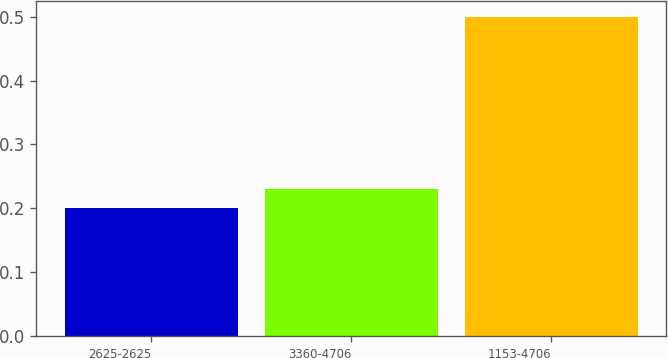Convert chart to OTSL. <chart><loc_0><loc_0><loc_500><loc_500><bar_chart><fcel>2625-2625<fcel>3360-4706<fcel>1153-4706<nl><fcel>0.2<fcel>0.23<fcel>0.5<nl></chart> 